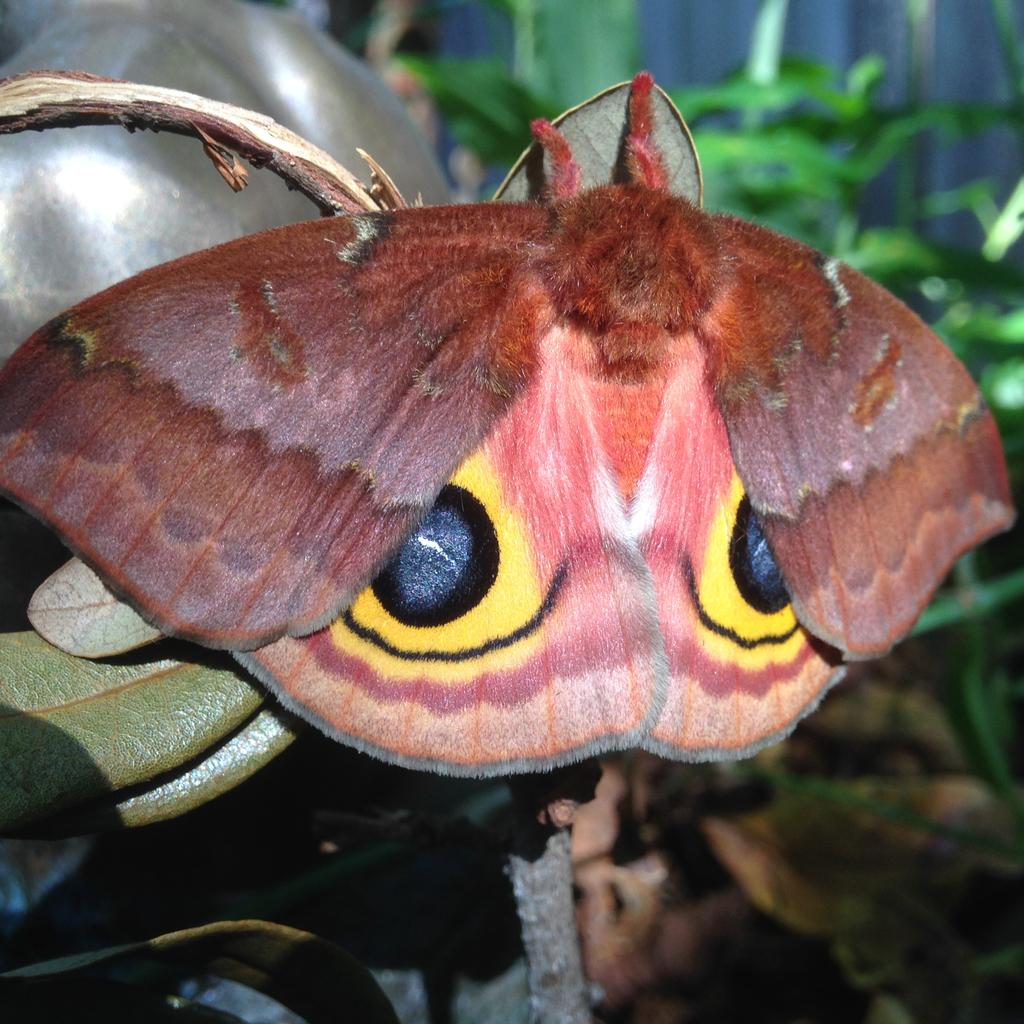What type of insect is present in the image? There is a brown butterfly in the image. What can be seen on the left side of the image? There is a plant on the left side of the image. What is visible in the background of the image? There are many plants visible in the background of the image. What type of car is parked behind the plant in the image? There is no car present in the image; it only features a brown butterfly, a plant on the left side, and many plants in the background. 